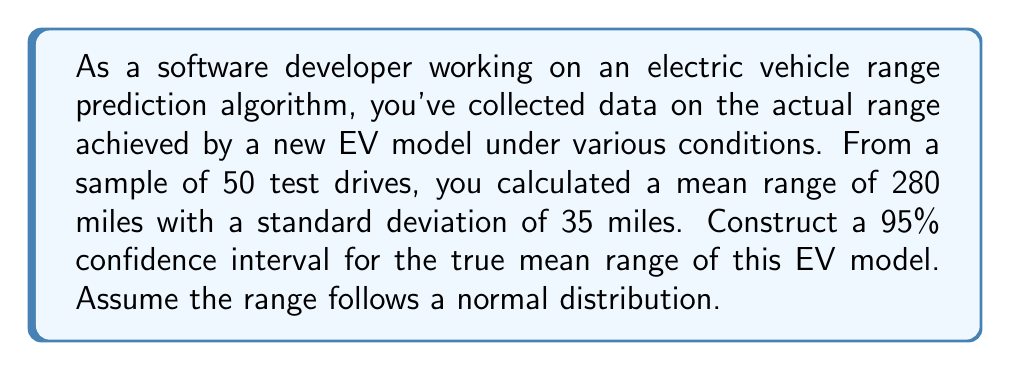Can you solve this math problem? To construct a 95% confidence interval for the true mean range, we'll follow these steps:

1. Identify the relevant information:
   - Sample size: $n = 50$
   - Sample mean: $\bar{x} = 280$ miles
   - Sample standard deviation: $s = 35$ miles
   - Confidence level: 95% (α = 0.05)

2. Determine the critical value:
   For a 95% confidence level and df = 49, the t-critical value is approximately 2.009 (from t-distribution table).

3. Calculate the margin of error:
   $\text{Margin of Error} = t_{\frac{\alpha}{2}, n-1} \cdot \frac{s}{\sqrt{n}}$
   $\text{Margin of Error} = 2.009 \cdot \frac{35}{\sqrt{50}} \approx 9.93$

4. Construct the confidence interval:
   $\text{CI} = \bar{x} \pm \text{Margin of Error}$
   $\text{CI} = 280 \pm 9.93$
   $\text{CI} = (270.07, 289.93)$

Therefore, we can be 95% confident that the true mean range of this EV model falls between 270.07 and 289.93 miles.
Answer: (270.07, 289.93) miles 